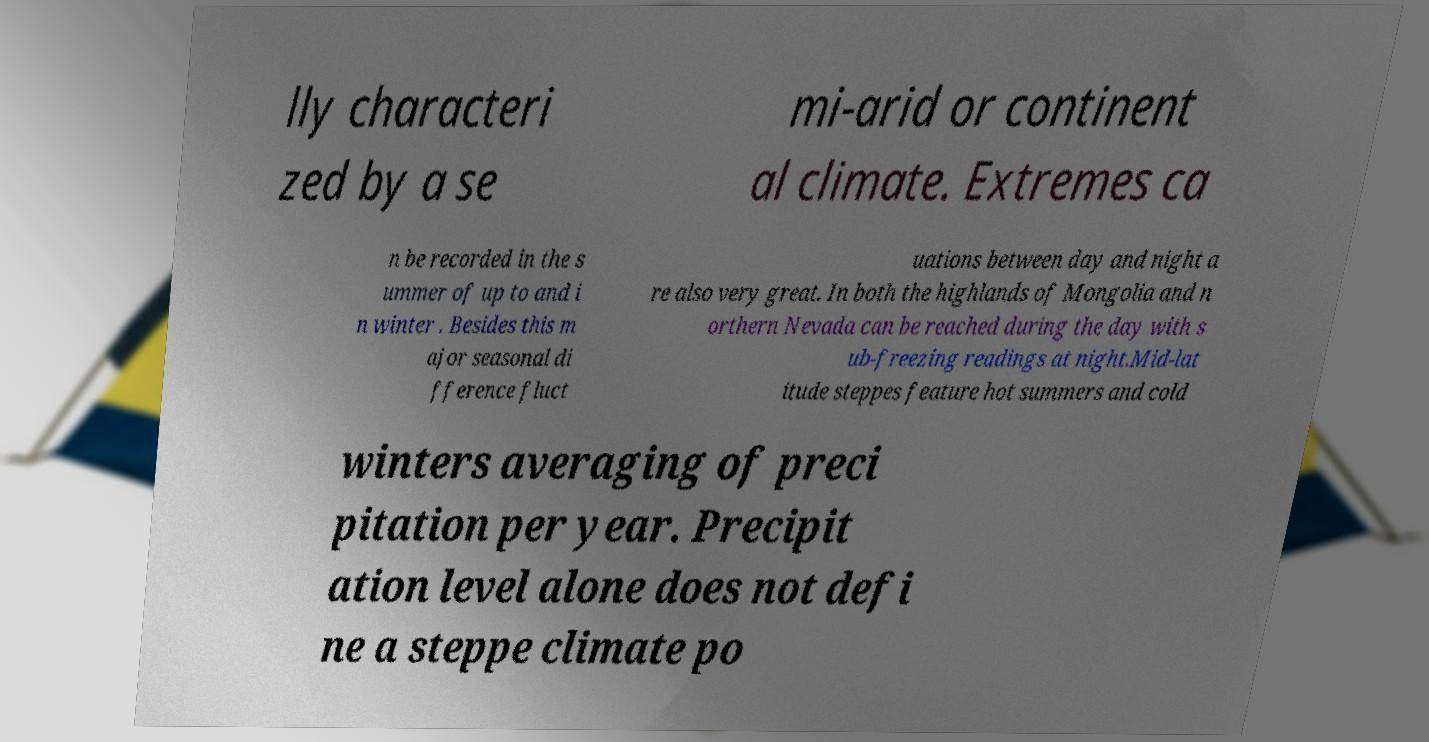Please read and relay the text visible in this image. What does it say? lly characteri zed by a se mi-arid or continent al climate. Extremes ca n be recorded in the s ummer of up to and i n winter . Besides this m ajor seasonal di fference fluct uations between day and night a re also very great. In both the highlands of Mongolia and n orthern Nevada can be reached during the day with s ub-freezing readings at night.Mid-lat itude steppes feature hot summers and cold winters averaging of preci pitation per year. Precipit ation level alone does not defi ne a steppe climate po 